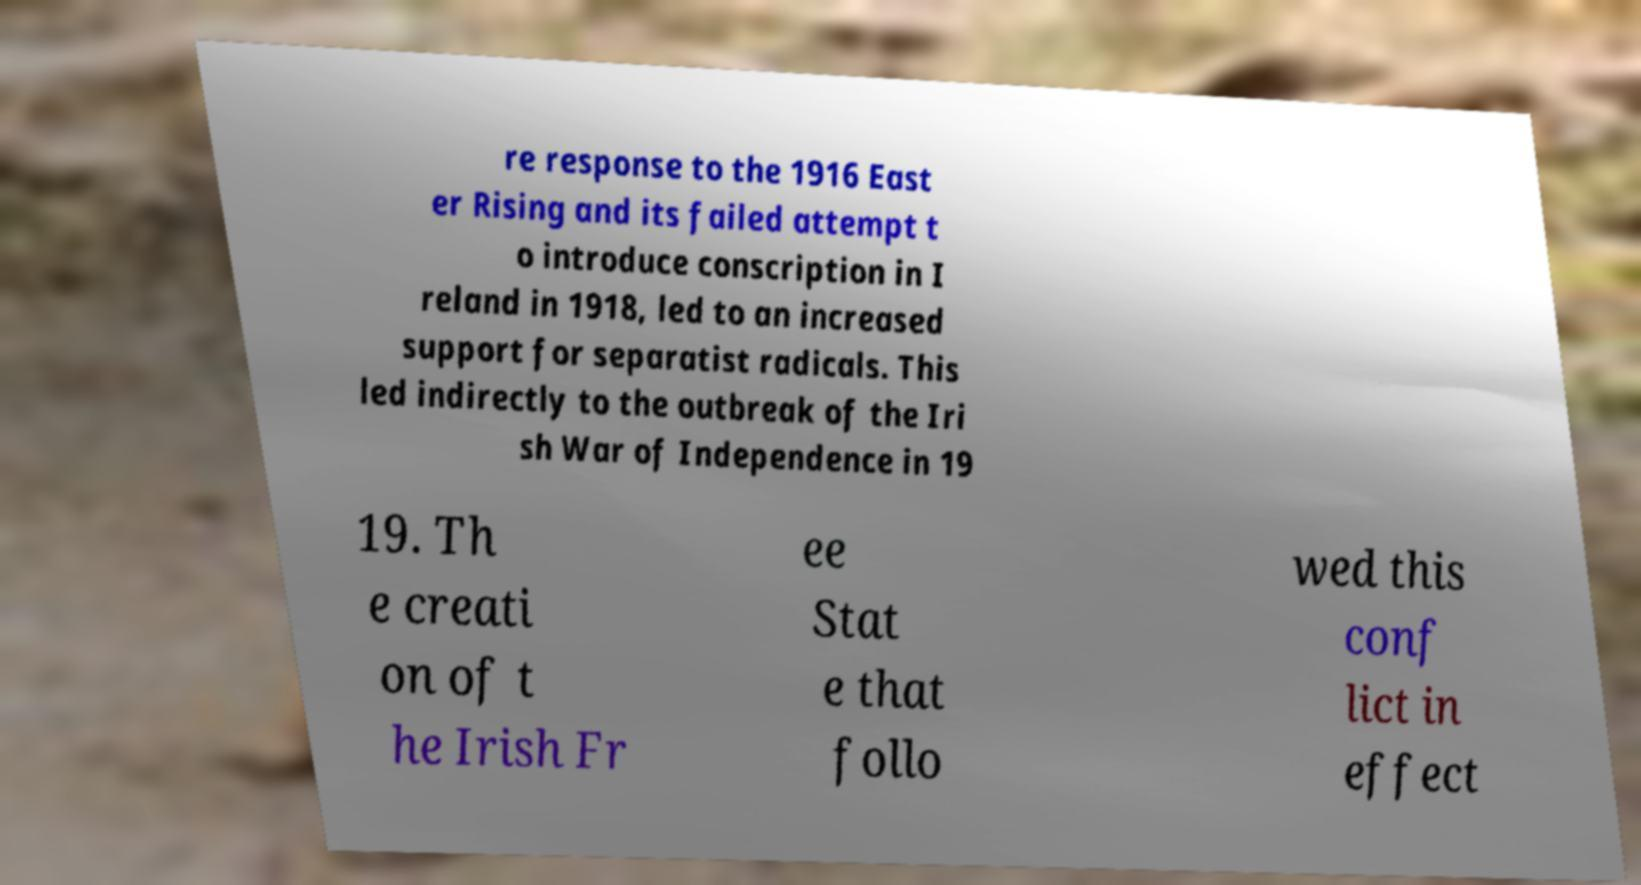There's text embedded in this image that I need extracted. Can you transcribe it verbatim? re response to the 1916 East er Rising and its failed attempt t o introduce conscription in I reland in 1918, led to an increased support for separatist radicals. This led indirectly to the outbreak of the Iri sh War of Independence in 19 19. Th e creati on of t he Irish Fr ee Stat e that follo wed this conf lict in effect 